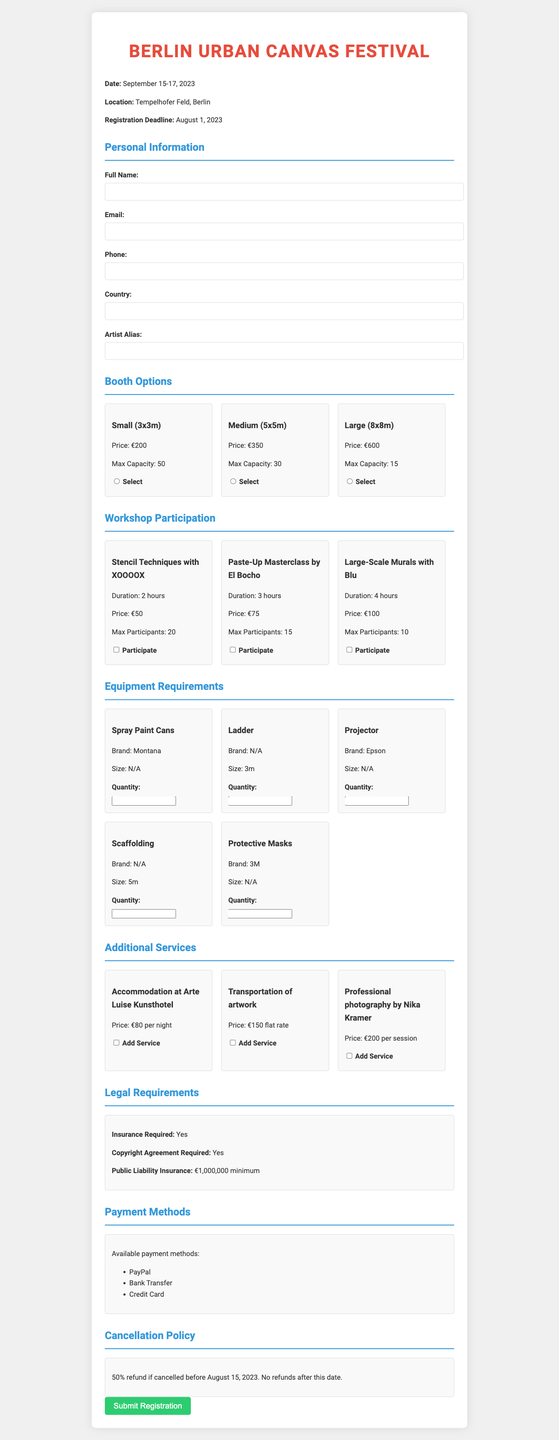what is the festival name? The festival name is provided at the top of the document.
Answer: Berlin Urban Canvas Festival what are the event dates? The event dates are listed prominently after the festival name.
Answer: September 15-17, 2023 how much is the price for a medium booth? The price for a medium booth option is mentioned in the booth section.
Answer: €350 who is conducting the Stencil Techniques workshop? The document states the name of the instructor for each workshop.
Answer: XOOOOX what is the maximum number of participants for the Large-Scale Murals workshop? This information can be found alongside each workshop's details.
Answer: 10 is accommodation available at Arte Luise Kunsthotel? The availability of additional services is detailed in the document.
Answer: Yes what is the minimum public liability insurance amount required? This amount is specified in the legal requirements section.
Answer: €1,000,000 how many different payment methods are accepted? The document lists all the payment methods available.
Answer: 3 what is the cancellation policy? The cancellation policy is outlined towards the end of the document.
Answer: 50% refund if cancelled before August 15, 2023. No refunds after this date 